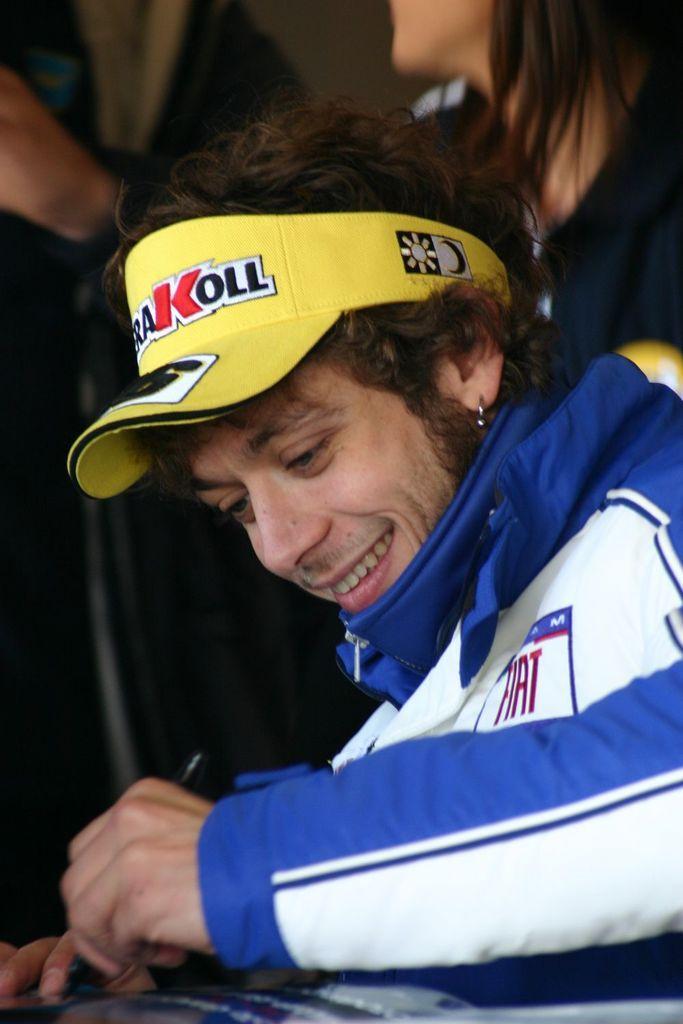Please provide a concise description of this image. In this image I can see a person sitting and smiling. And he is holding a pen and wearing a yellow color cap. 